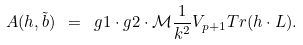<formula> <loc_0><loc_0><loc_500><loc_500>A ( h , \tilde { b } ) \ = \ g 1 \cdot g 2 \cdot \mathcal { M } \frac { 1 } { k ^ { 2 } } V _ { p + 1 } T r ( h \cdot L ) .</formula> 